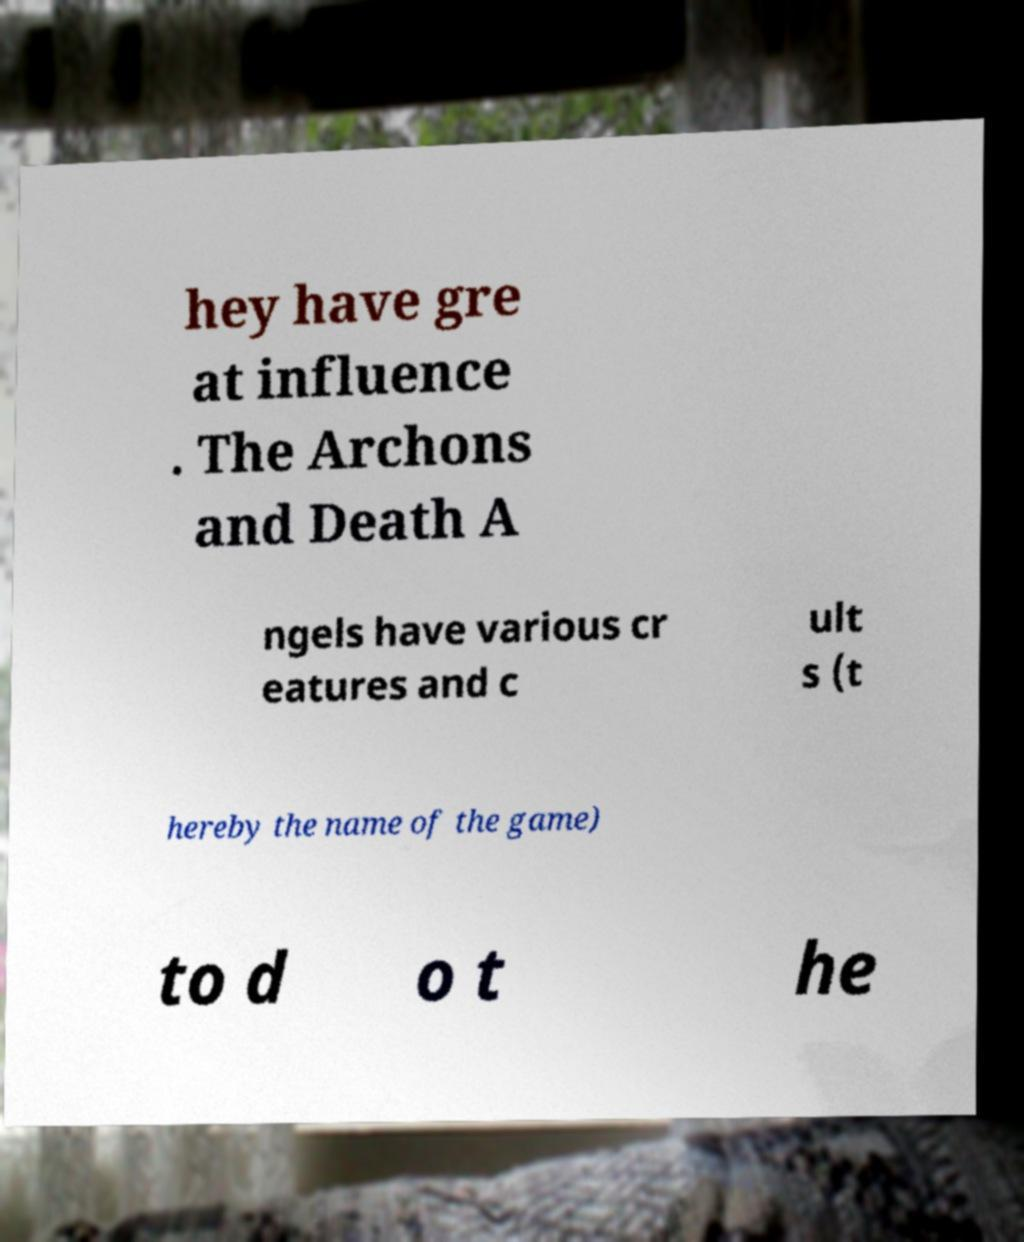Could you assist in decoding the text presented in this image and type it out clearly? hey have gre at influence . The Archons and Death A ngels have various cr eatures and c ult s (t hereby the name of the game) to d o t he 